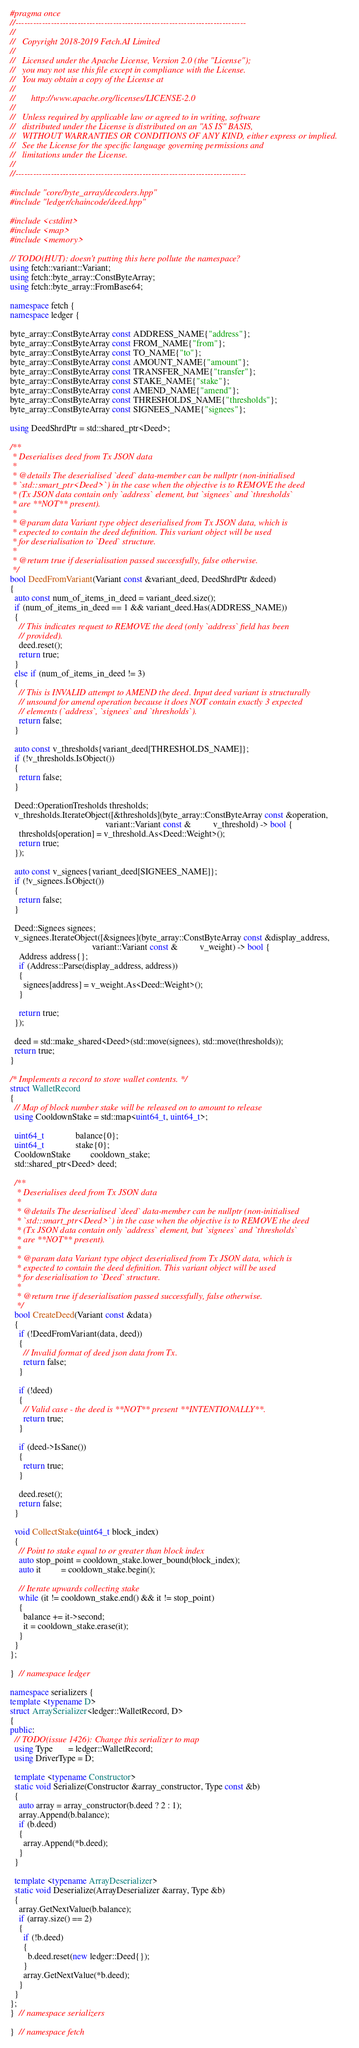<code> <loc_0><loc_0><loc_500><loc_500><_C++_>#pragma once
//------------------------------------------------------------------------------
//
//   Copyright 2018-2019 Fetch.AI Limited
//
//   Licensed under the Apache License, Version 2.0 (the "License");
//   you may not use this file except in compliance with the License.
//   You may obtain a copy of the License at
//
//       http://www.apache.org/licenses/LICENSE-2.0
//
//   Unless required by applicable law or agreed to in writing, software
//   distributed under the License is distributed on an "AS IS" BASIS,
//   WITHOUT WARRANTIES OR CONDITIONS OF ANY KIND, either express or implied.
//   See the License for the specific language governing permissions and
//   limitations under the License.
//
//------------------------------------------------------------------------------

#include "core/byte_array/decoders.hpp"
#include "ledger/chaincode/deed.hpp"

#include <cstdint>
#include <map>
#include <memory>

// TODO(HUT): doesn't putting this here pollute the namespace?
using fetch::variant::Variant;
using fetch::byte_array::ConstByteArray;
using fetch::byte_array::FromBase64;

namespace fetch {
namespace ledger {

byte_array::ConstByteArray const ADDRESS_NAME{"address"};
byte_array::ConstByteArray const FROM_NAME{"from"};
byte_array::ConstByteArray const TO_NAME{"to"};
byte_array::ConstByteArray const AMOUNT_NAME{"amount"};
byte_array::ConstByteArray const TRANSFER_NAME{"transfer"};
byte_array::ConstByteArray const STAKE_NAME{"stake"};
byte_array::ConstByteArray const AMEND_NAME{"amend"};
byte_array::ConstByteArray const THRESHOLDS_NAME{"thresholds"};
byte_array::ConstByteArray const SIGNEES_NAME{"signees"};

using DeedShrdPtr = std::shared_ptr<Deed>;

/**
 * Deserialises deed from Tx JSON data
 *
 * @details The deserialised `deed` data-member can be nullptr (non-initialised
 * `std::smart_ptr<Deed>`) in the case when the objective is to REMOVE the deed
 * (Tx JSON data contain only `address` element, but `signees` and `thresholds`
 * are **NOT** present).
 *
 * @param data Variant type object deserialised from Tx JSON data, which is
 * expected to contain the deed definition. This variant object will be used
 * for deserialisation to `Deed` structure.
 *
 * @return true if deserialisation passed successfully, false otherwise.
 */
bool DeedFromVariant(Variant const &variant_deed, DeedShrdPtr &deed)
{
  auto const num_of_items_in_deed = variant_deed.size();
  if (num_of_items_in_deed == 1 && variant_deed.Has(ADDRESS_NAME))
  {
    // This indicates request to REMOVE the deed (only `address` field has been
    // provided).
    deed.reset();
    return true;
  }
  else if (num_of_items_in_deed != 3)
  {
    // This is INVALID attempt to AMEND the deed. Input deed variant is structurally
    // unsound for amend operation because it does NOT contain exactly 3 expected
    // elements (`address`, `signees` and `thresholds`).
    return false;
  }

  auto const v_thresholds{variant_deed[THRESHOLDS_NAME]};
  if (!v_thresholds.IsObject())
  {
    return false;
  }

  Deed::OperationTresholds thresholds;
  v_thresholds.IterateObject([&thresholds](byte_array::ConstByteArray const &operation,
                                           variant::Variant const &          v_threshold) -> bool {
    thresholds[operation] = v_threshold.As<Deed::Weight>();
    return true;
  });

  auto const v_signees{variant_deed[SIGNEES_NAME]};
  if (!v_signees.IsObject())
  {
    return false;
  }

  Deed::Signees signees;
  v_signees.IterateObject([&signees](byte_array::ConstByteArray const &display_address,
                                     variant::Variant const &          v_weight) -> bool {
    Address address{};
    if (Address::Parse(display_address, address))
    {
      signees[address] = v_weight.As<Deed::Weight>();
    }

    return true;
  });

  deed = std::make_shared<Deed>(std::move(signees), std::move(thresholds));
  return true;
}

/* Implements a record to store wallet contents. */
struct WalletRecord
{
  // Map of block number stake will be released on to amount to release
  using CooldownStake = std::map<uint64_t, uint64_t>;

  uint64_t              balance{0};
  uint64_t              stake{0};
  CooldownStake         cooldown_stake;
  std::shared_ptr<Deed> deed;

  /**
   * Deserialises deed from Tx JSON data
   *
   * @details The deserialised `deed` data-member can be nullptr (non-initialised
   * `std::smart_ptr<Deed>`) in the case when the objective is to REMOVE the deed
   * (Tx JSON data contain only `address` element, but `signees` and `thresholds`
   * are **NOT** present).
   *
   * @param data Variant type object deserialised from Tx JSON data, which is
   * expected to contain the deed definition. This variant object will be used
   * for deserialisation to `Deed` structure.
   *
   * @return true if deserialisation passed successfully, false otherwise.
   */
  bool CreateDeed(Variant const &data)
  {
    if (!DeedFromVariant(data, deed))
    {
      // Invalid format of deed json data from Tx.
      return false;
    }

    if (!deed)
    {
      // Valid case - the deed is **NOT** present **INTENTIONALLY**.
      return true;
    }

    if (deed->IsSane())
    {
      return true;
    }

    deed.reset();
    return false;
  }

  void CollectStake(uint64_t block_index)
  {
    // Point to stake equal to or greater than block index
    auto stop_point = cooldown_stake.lower_bound(block_index);
    auto it         = cooldown_stake.begin();

    // Iterate upwards collecting stake
    while (it != cooldown_stake.end() && it != stop_point)
    {
      balance += it->second;
      it = cooldown_stake.erase(it);
    }
  }
};

}  // namespace ledger

namespace serializers {
template <typename D>
struct ArraySerializer<ledger::WalletRecord, D>
{
public:
  // TODO(issue 1426): Change this serializer to map
  using Type       = ledger::WalletRecord;
  using DriverType = D;

  template <typename Constructor>
  static void Serialize(Constructor &array_constructor, Type const &b)
  {
    auto array = array_constructor(b.deed ? 2 : 1);
    array.Append(b.balance);
    if (b.deed)
    {
      array.Append(*b.deed);
    }
  }

  template <typename ArrayDeserializer>
  static void Deserialize(ArrayDeserializer &array, Type &b)
  {
    array.GetNextValue(b.balance);
    if (array.size() == 2)
    {
      if (!b.deed)
      {
        b.deed.reset(new ledger::Deed{});
      }
      array.GetNextValue(*b.deed);
    }
  }
};
}  // namespace serializers

}  // namespace fetch
</code> 